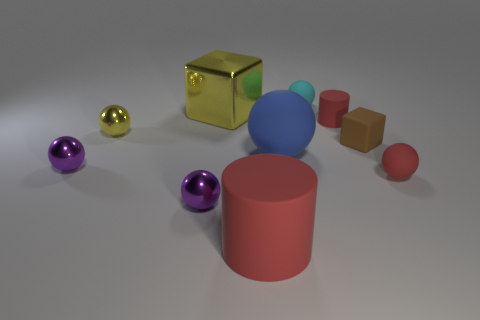There is a shiny thing behind the small red cylinder; is its shape the same as the tiny thing on the right side of the rubber cube?
Make the answer very short. No. What number of things are either yellow cubes or purple rubber balls?
Ensure brevity in your answer.  1. The blue rubber thing that is the same shape as the small yellow thing is what size?
Your answer should be very brief. Large. Is the number of tiny things that are in front of the brown thing greater than the number of big gray matte balls?
Ensure brevity in your answer.  Yes. Are the brown object and the small cylinder made of the same material?
Keep it short and to the point. Yes. How many objects are red rubber cylinders behind the big matte sphere or red rubber objects that are in front of the tiny red rubber cylinder?
Provide a succinct answer. 3. What is the color of the large matte object that is the same shape as the small cyan thing?
Your response must be concise. Blue. How many small blocks are the same color as the big metallic cube?
Make the answer very short. 0. Is the color of the tiny cylinder the same as the large matte cylinder?
Your answer should be very brief. Yes. What number of things are things that are behind the big blue sphere or tiny brown matte blocks?
Provide a succinct answer. 5. 